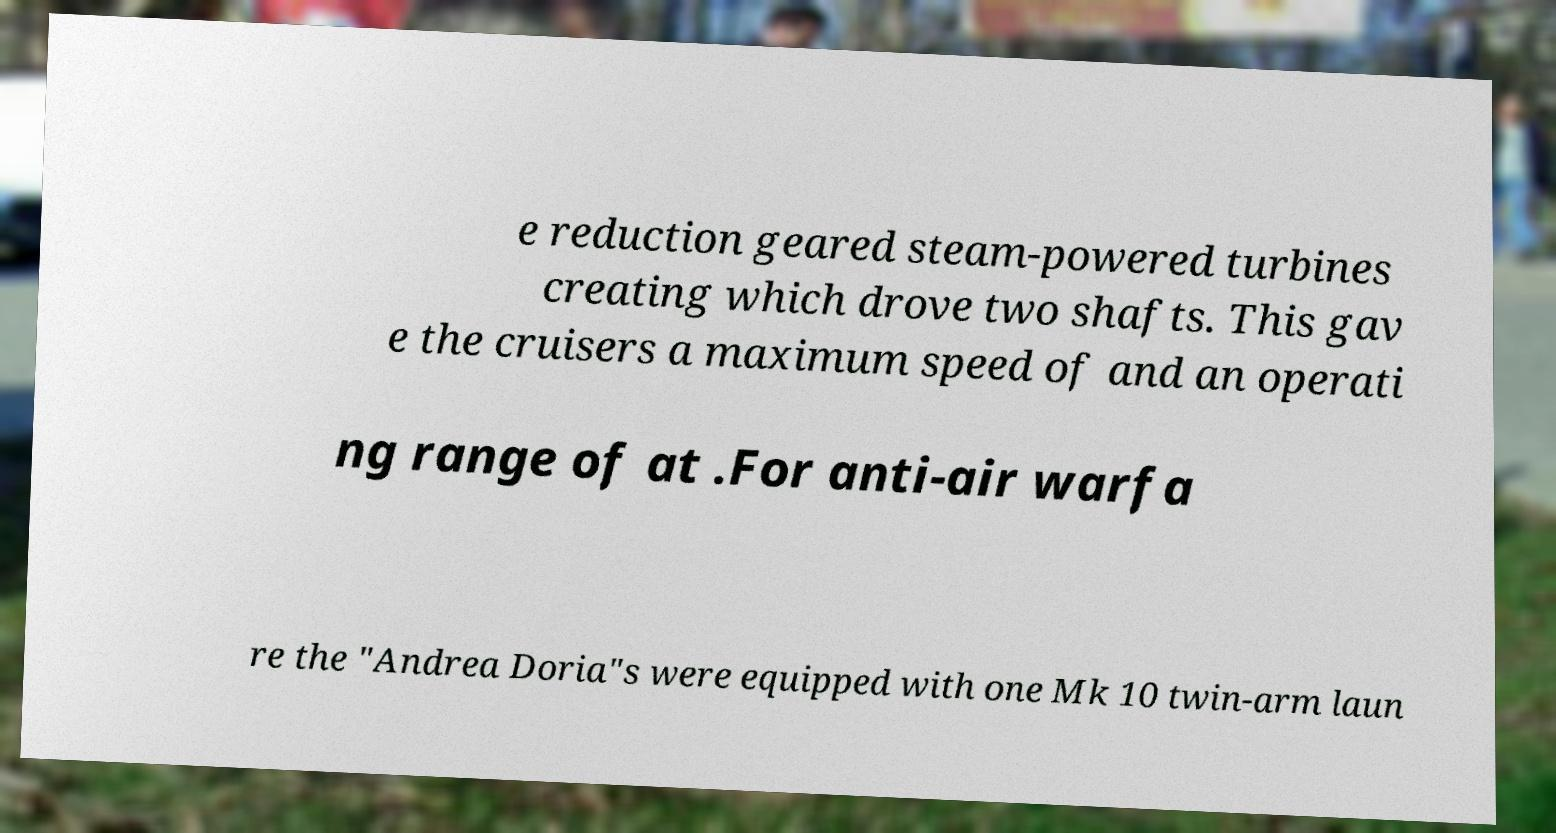Can you accurately transcribe the text from the provided image for me? e reduction geared steam-powered turbines creating which drove two shafts. This gav e the cruisers a maximum speed of and an operati ng range of at .For anti-air warfa re the "Andrea Doria"s were equipped with one Mk 10 twin-arm laun 